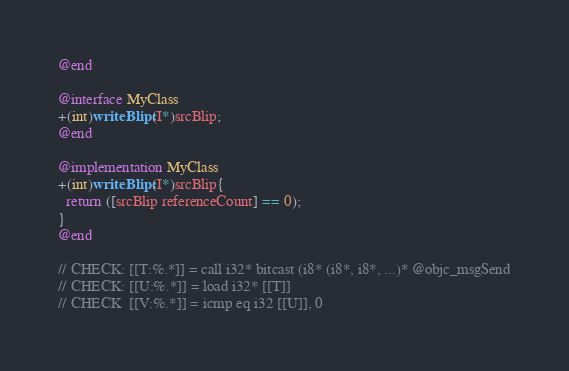<code> <loc_0><loc_0><loc_500><loc_500><_ObjectiveC_>@end

@interface MyClass
+(int)writeBlip:(I*)srcBlip;
@end

@implementation MyClass
+(int)writeBlip:(I*)srcBlip{
  return ([srcBlip referenceCount] == 0);
}
@end

// CHECK: [[T:%.*]] = call i32* bitcast (i8* (i8*, i8*, ...)* @objc_msgSend
// CHECK: [[U:%.*]] = load i32* [[T]]
// CHECK  [[V:%.*]] = icmp eq i32 [[U]], 0
</code> 